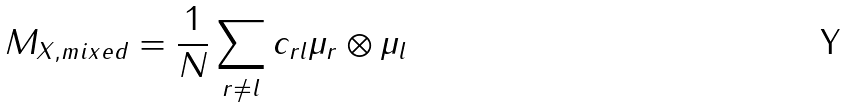<formula> <loc_0><loc_0><loc_500><loc_500>M _ { X , m i x e d } = \frac { 1 } { N } \sum _ { r \neq l } c _ { r l } \mu _ { r } \otimes \mu _ { l }</formula> 